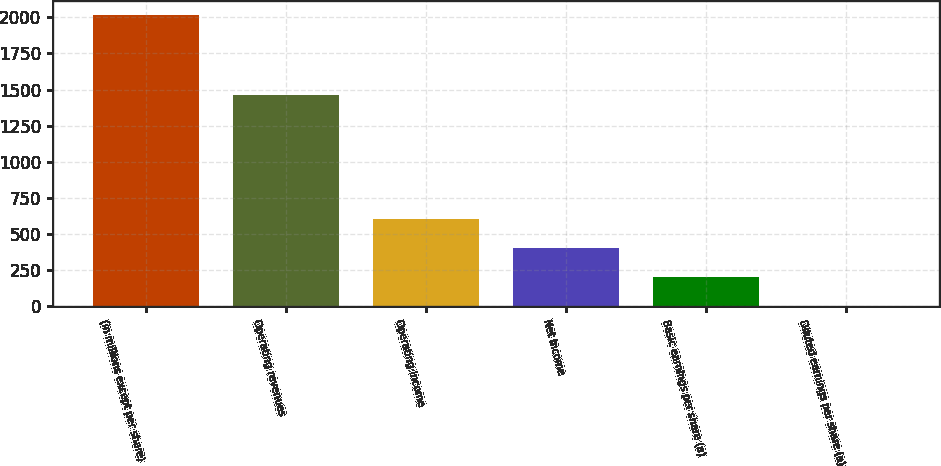Convert chart. <chart><loc_0><loc_0><loc_500><loc_500><bar_chart><fcel>(in millions except per share)<fcel>Operating revenues<fcel>Operating income<fcel>Net income<fcel>Basic earnings per share (a)<fcel>Diluted earnings per share (a)<nl><fcel>2014<fcel>1465<fcel>605.2<fcel>403.95<fcel>202.7<fcel>1.45<nl></chart> 